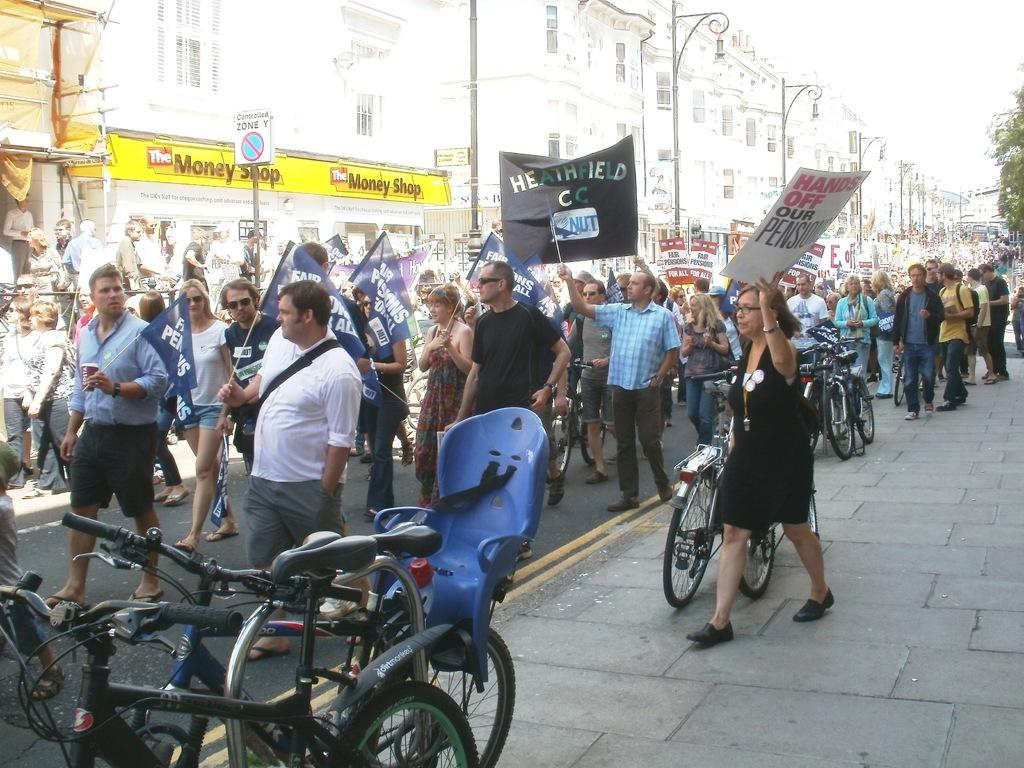What is happening with the group of people in the image? The people are walking in the image. What can be seen in the background of the image? There is a building in the background of the image. What else is present in the image besides the group of people? There are bicycles in the image. What scientific experiment is being conducted by the group of people in the image? There is no indication of a scientific experiment being conducted in the image; the group of people is simply walking. 